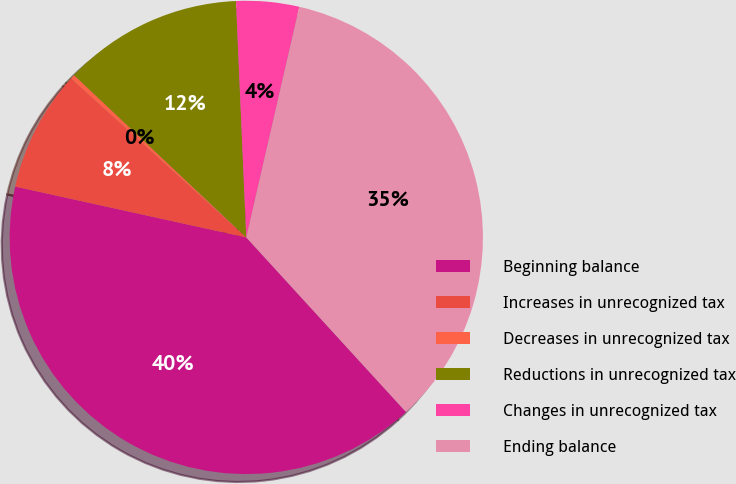<chart> <loc_0><loc_0><loc_500><loc_500><pie_chart><fcel>Beginning balance<fcel>Increases in unrecognized tax<fcel>Decreases in unrecognized tax<fcel>Reductions in unrecognized tax<fcel>Changes in unrecognized tax<fcel>Ending balance<nl><fcel>40.24%<fcel>8.28%<fcel>0.3%<fcel>12.28%<fcel>4.29%<fcel>34.61%<nl></chart> 